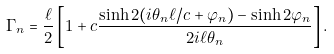Convert formula to latex. <formula><loc_0><loc_0><loc_500><loc_500>\Gamma _ { n } = \frac { \ell } { 2 } \left [ 1 + c \frac { \sinh 2 ( i \theta _ { n } \ell / c + \varphi _ { n } ) - \sinh 2 \varphi _ { n } } { 2 i \ell \theta _ { n } } \right ] .</formula> 